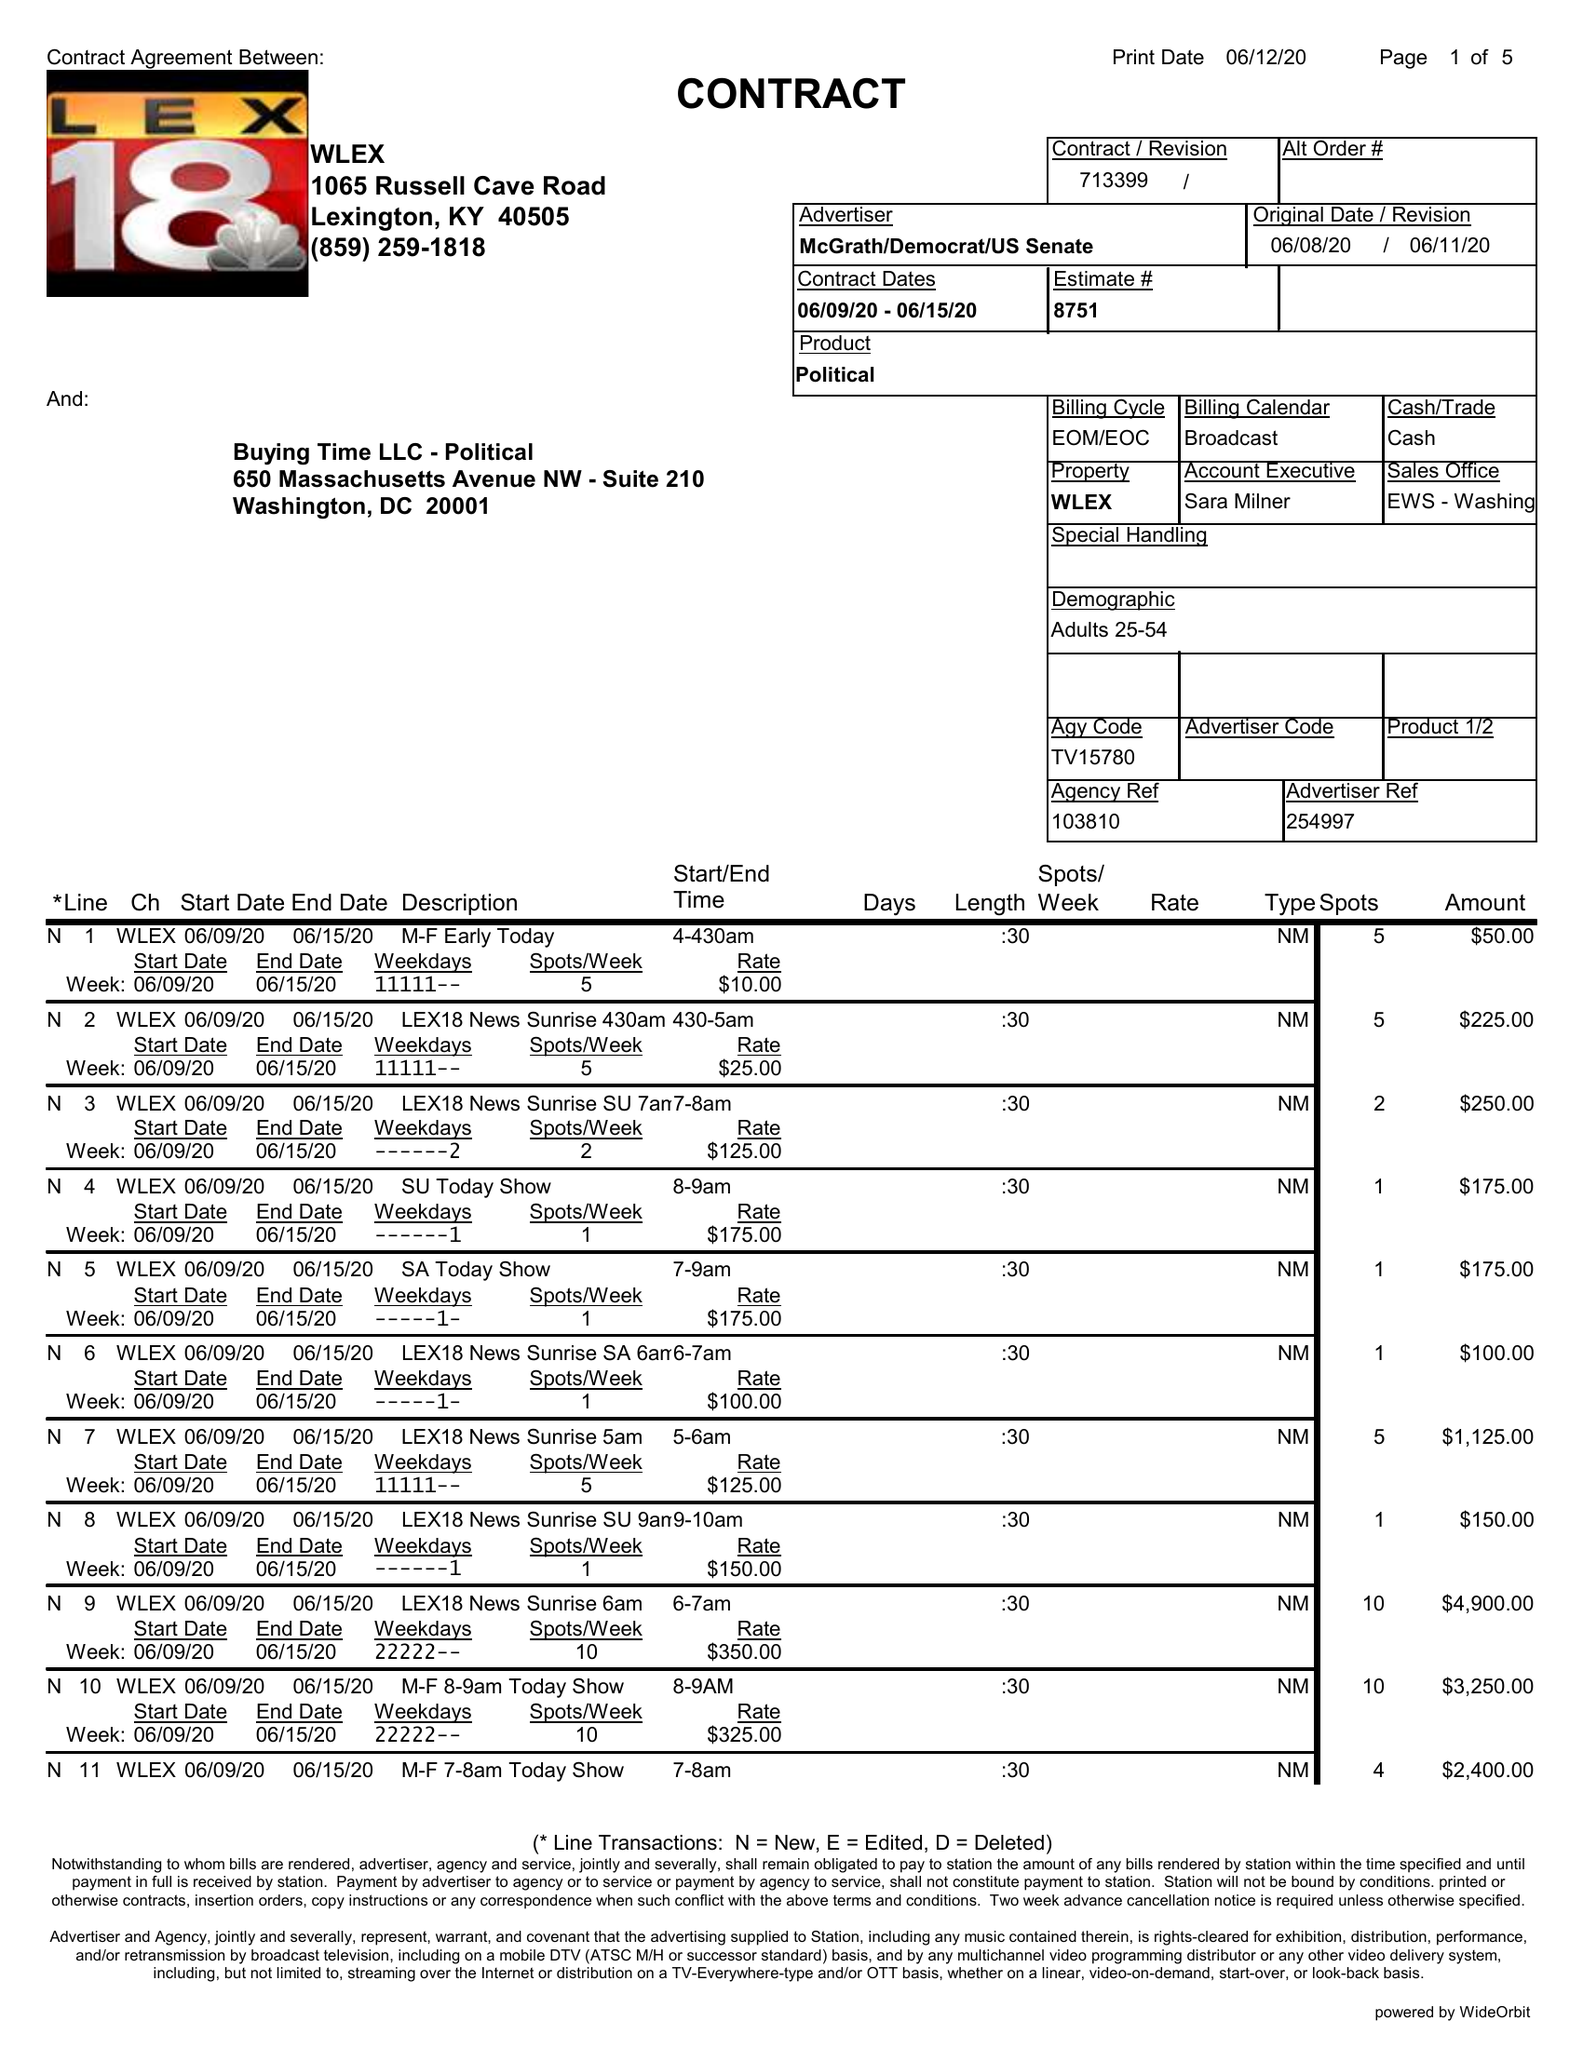What is the value for the gross_amount?
Answer the question using a single word or phrase. 41575.00 